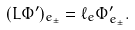<formula> <loc_0><loc_0><loc_500><loc_500>( L \Phi ^ { \prime } ) _ { e _ { \pm } } = \ell _ { e } \Phi ^ { \prime } _ { e _ { \pm } } .</formula> 